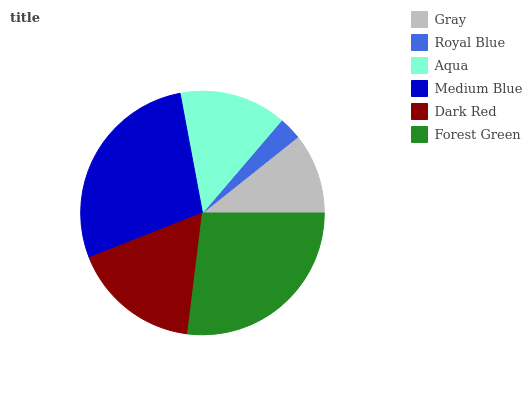Is Royal Blue the minimum?
Answer yes or no. Yes. Is Medium Blue the maximum?
Answer yes or no. Yes. Is Aqua the minimum?
Answer yes or no. No. Is Aqua the maximum?
Answer yes or no. No. Is Aqua greater than Royal Blue?
Answer yes or no. Yes. Is Royal Blue less than Aqua?
Answer yes or no. Yes. Is Royal Blue greater than Aqua?
Answer yes or no. No. Is Aqua less than Royal Blue?
Answer yes or no. No. Is Dark Red the high median?
Answer yes or no. Yes. Is Aqua the low median?
Answer yes or no. Yes. Is Medium Blue the high median?
Answer yes or no. No. Is Royal Blue the low median?
Answer yes or no. No. 